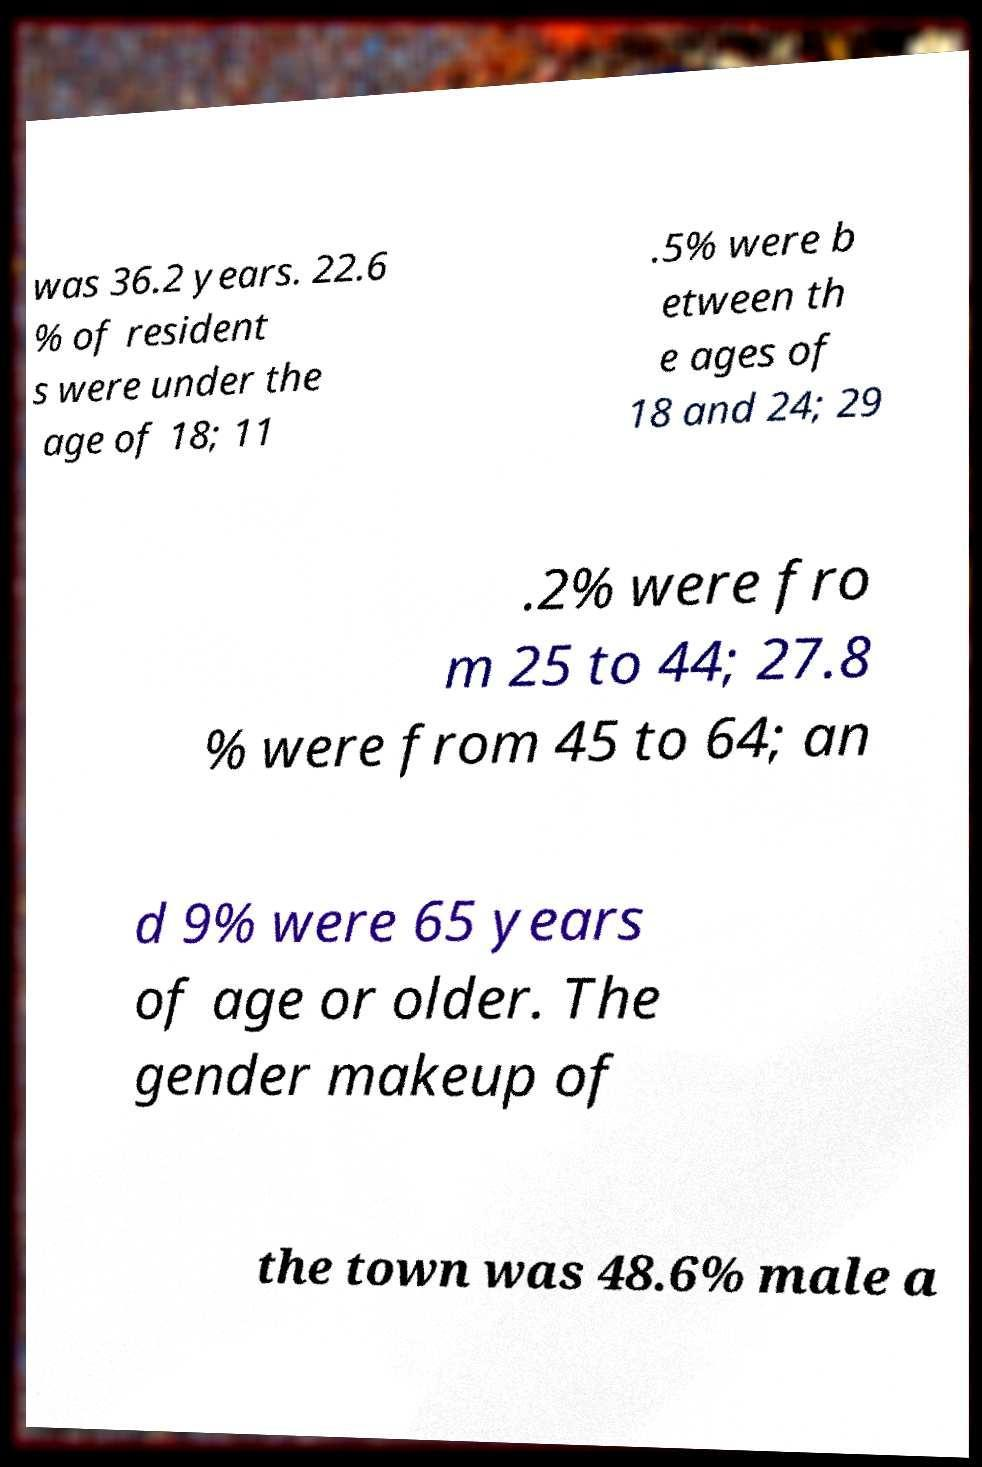There's text embedded in this image that I need extracted. Can you transcribe it verbatim? was 36.2 years. 22.6 % of resident s were under the age of 18; 11 .5% were b etween th e ages of 18 and 24; 29 .2% were fro m 25 to 44; 27.8 % were from 45 to 64; an d 9% were 65 years of age or older. The gender makeup of the town was 48.6% male a 